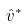<formula> <loc_0><loc_0><loc_500><loc_500>\hat { v } ^ { * }</formula> 